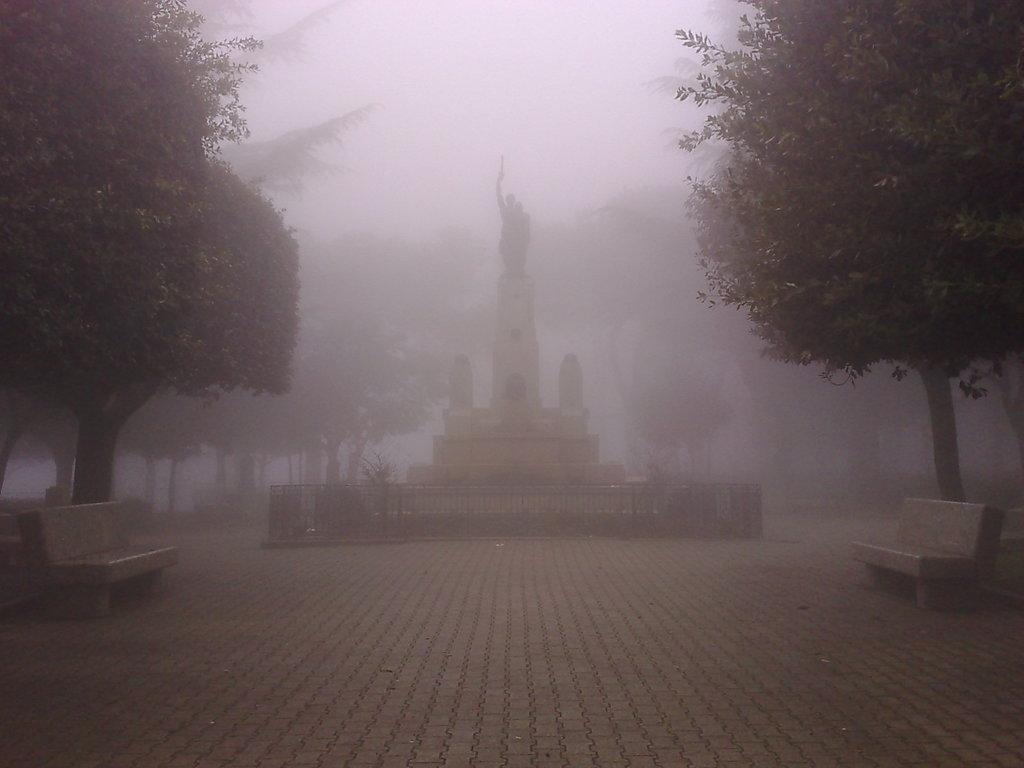Please provide a concise description of this image. This is an outside view. In this image I can see the fog. On the right and left side of the image there are trees and benches on the ground. In the background there is a statue on a pillar and also I can see few trees. Around this pillar there is a railing. 